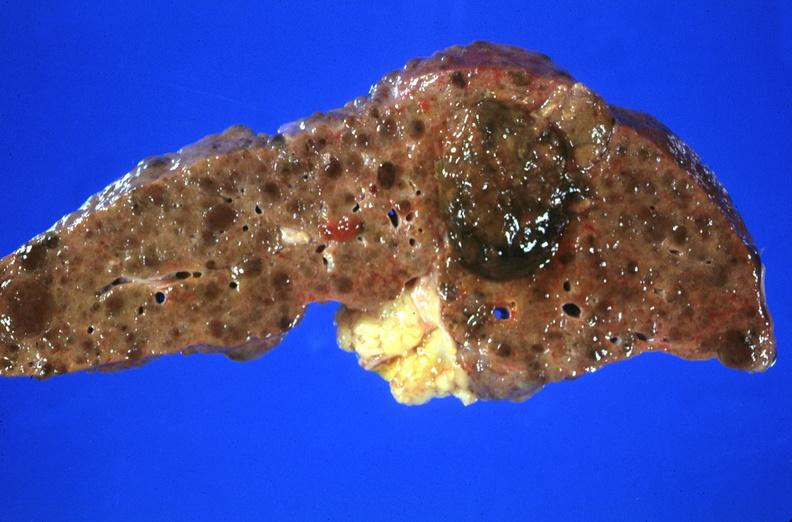what does this image show?
Answer the question using a single word or phrase. Hepatitis b virus 